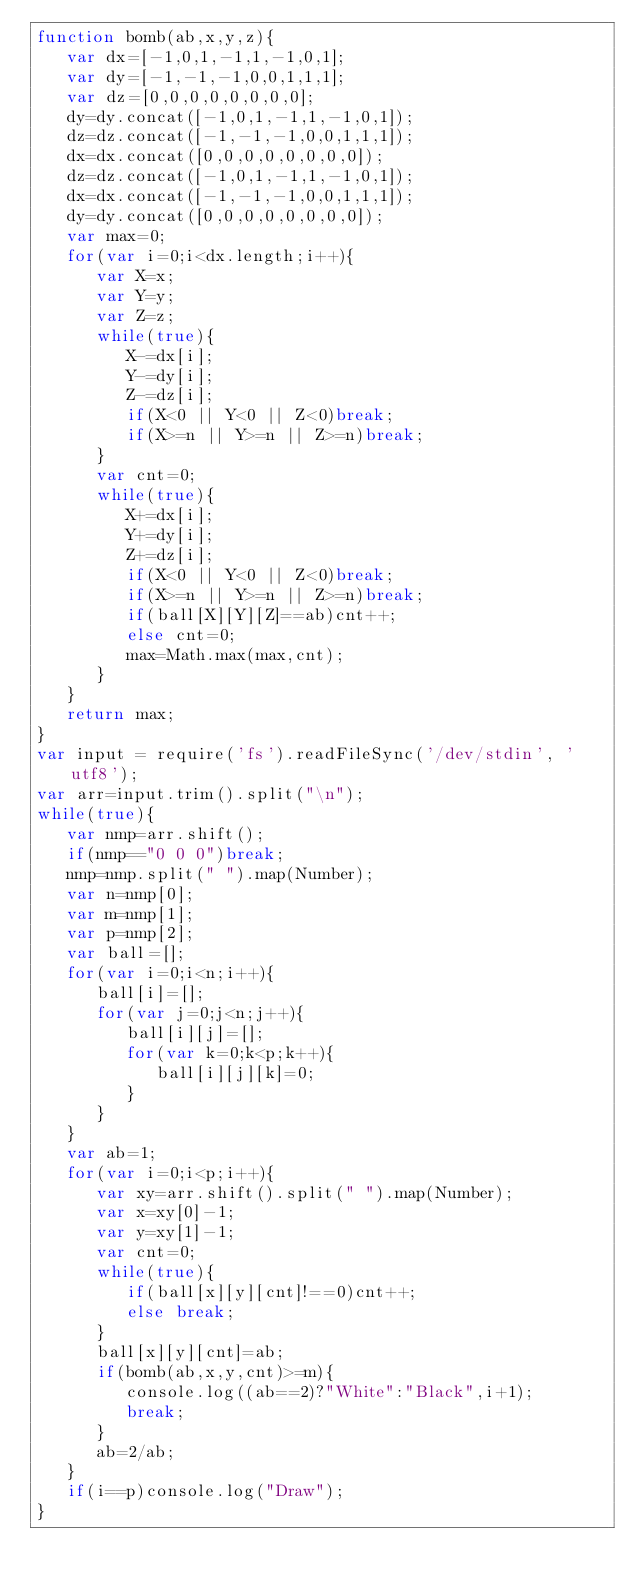Convert code to text. <code><loc_0><loc_0><loc_500><loc_500><_JavaScript_>function bomb(ab,x,y,z){
   var dx=[-1,0,1,-1,1,-1,0,1];
   var dy=[-1,-1,-1,0,0,1,1,1];
   var dz=[0,0,0,0,0,0,0,0];
   dy=dy.concat([-1,0,1,-1,1,-1,0,1]);
   dz=dz.concat([-1,-1,-1,0,0,1,1,1]);
   dx=dx.concat([0,0,0,0,0,0,0,0]);
   dz=dz.concat([-1,0,1,-1,1,-1,0,1]);
   dx=dx.concat([-1,-1,-1,0,0,1,1,1]);
   dy=dy.concat([0,0,0,0,0,0,0,0]);
   var max=0;
   for(var i=0;i<dx.length;i++){
      var X=x;
      var Y=y;
      var Z=z;
      while(true){
         X-=dx[i];
         Y-=dy[i];
         Z-=dz[i];
         if(X<0 || Y<0 || Z<0)break;
         if(X>=n || Y>=n || Z>=n)break;
      }
      var cnt=0;
      while(true){
         X+=dx[i];
         Y+=dy[i];
         Z+=dz[i];
         if(X<0 || Y<0 || Z<0)break;
         if(X>=n || Y>=n || Z>=n)break;
         if(ball[X][Y][Z]==ab)cnt++;
         else cnt=0;
         max=Math.max(max,cnt);
      }
   }
   return max;
}
var input = require('fs').readFileSync('/dev/stdin', 'utf8');
var arr=input.trim().split("\n");
while(true){
   var nmp=arr.shift();
   if(nmp=="0 0 0")break;
   nmp=nmp.split(" ").map(Number);
   var n=nmp[0];
   var m=nmp[1];
   var p=nmp[2];
   var ball=[];
   for(var i=0;i<n;i++){
      ball[i]=[];
      for(var j=0;j<n;j++){
         ball[i][j]=[];
         for(var k=0;k<p;k++){
            ball[i][j][k]=0;
         }
      }
   }
   var ab=1;
   for(var i=0;i<p;i++){
      var xy=arr.shift().split(" ").map(Number);
      var x=xy[0]-1;
      var y=xy[1]-1;
      var cnt=0;
      while(true){
         if(ball[x][y][cnt]!==0)cnt++;
         else break;
      }
      ball[x][y][cnt]=ab;
      if(bomb(ab,x,y,cnt)>=m){
         console.log((ab==2)?"White":"Black",i+1);
         break;
      }
      ab=2/ab;
   }
   if(i==p)console.log("Draw");
}</code> 